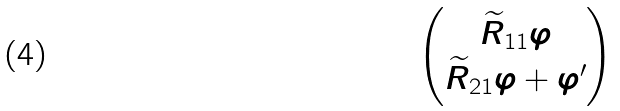Convert formula to latex. <formula><loc_0><loc_0><loc_500><loc_500>\begin{pmatrix} \widetilde { R } _ { 1 1 } \varphi \\ \widetilde { R } _ { 2 1 } \varphi + \varphi ^ { \prime } \end{pmatrix}</formula> 